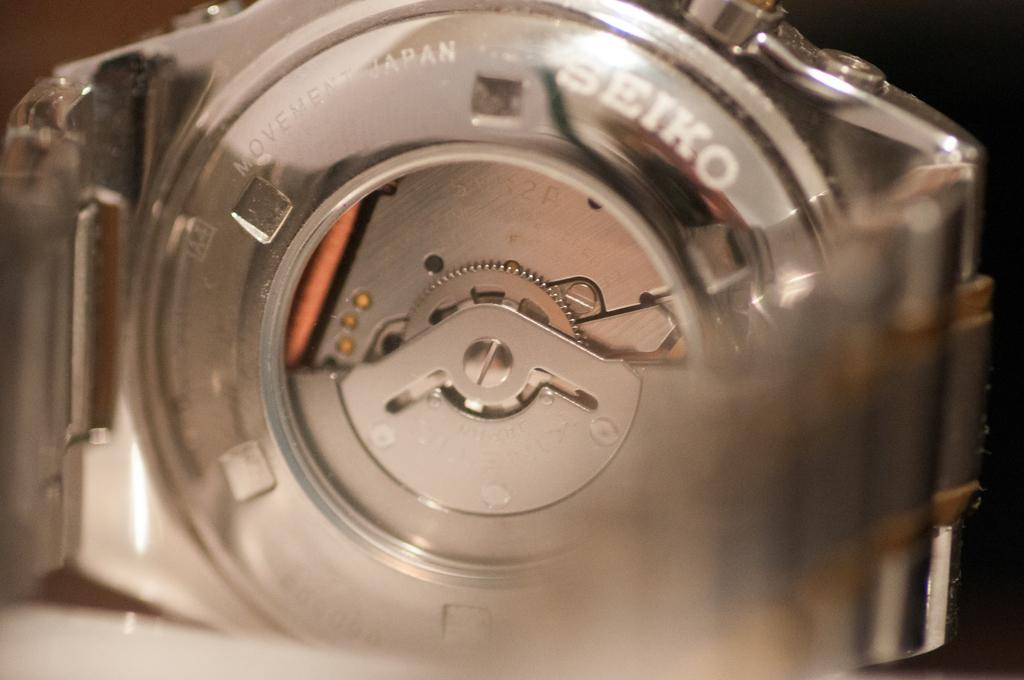Provide a one-sentence caption for the provided image. A close up view of the back of a Seiko watch. 